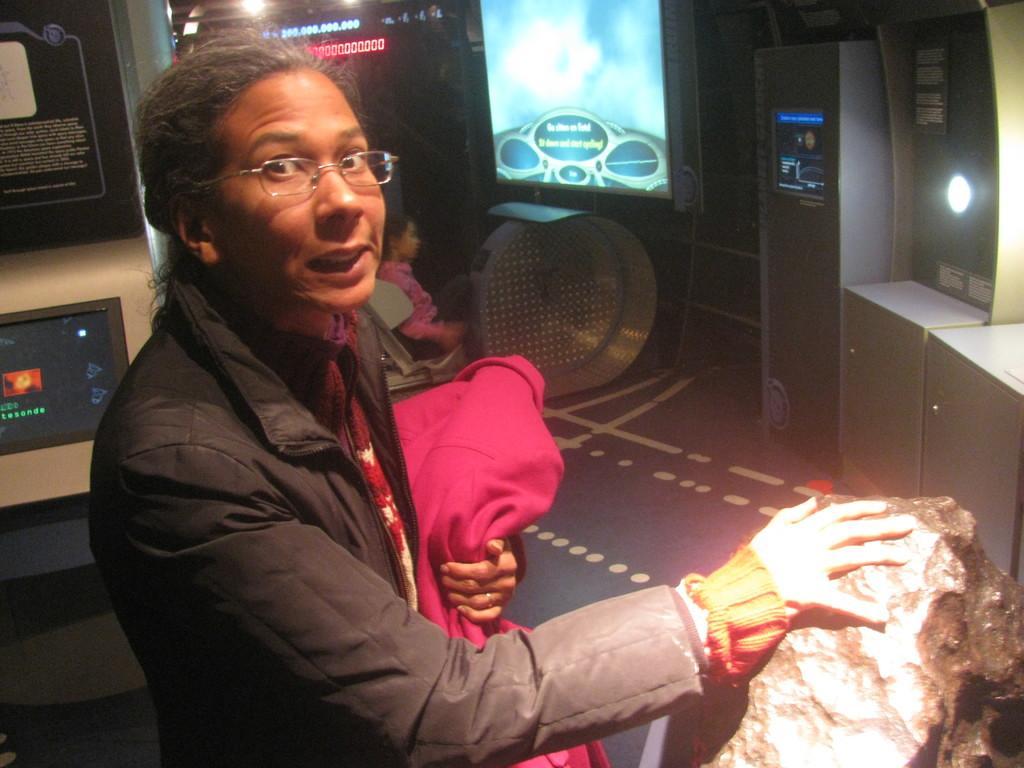Please provide a concise description of this image. In this image, we can see a person wearing clothes and spectacles. There is a rock in the bottom right of the image. There is an another person in the middle of the image sitting on the chair. In the background of the image, we can see some machines. 